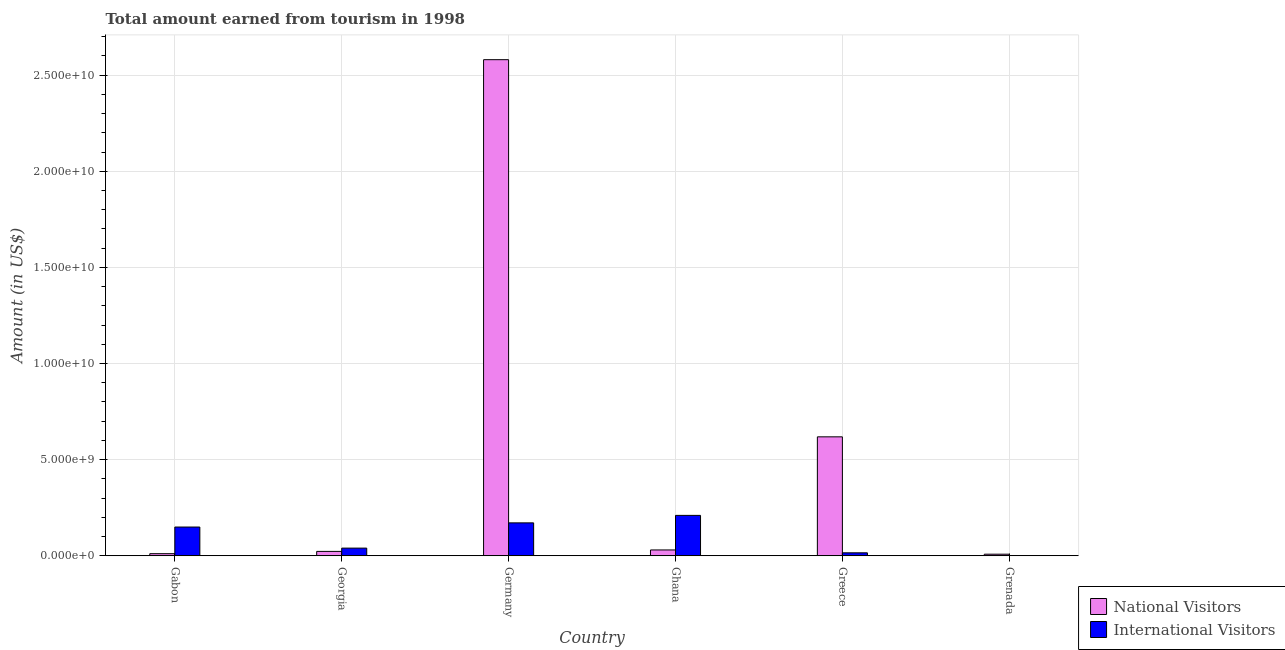Are the number of bars on each tick of the X-axis equal?
Your answer should be compact. Yes. How many bars are there on the 3rd tick from the left?
Ensure brevity in your answer.  2. What is the label of the 6th group of bars from the left?
Your response must be concise. Grenada. What is the amount earned from international visitors in Grenada?
Provide a succinct answer. 1.40e+07. Across all countries, what is the maximum amount earned from international visitors?
Offer a terse response. 2.10e+09. Across all countries, what is the minimum amount earned from international visitors?
Keep it short and to the point. 1.40e+07. In which country was the amount earned from international visitors maximum?
Your answer should be compact. Ghana. In which country was the amount earned from international visitors minimum?
Your answer should be compact. Grenada. What is the total amount earned from national visitors in the graph?
Your answer should be very brief. 3.27e+1. What is the difference between the amount earned from international visitors in Ghana and that in Grenada?
Provide a short and direct response. 2.09e+09. What is the difference between the amount earned from international visitors in Georgia and the amount earned from national visitors in Greece?
Keep it short and to the point. -5.79e+09. What is the average amount earned from international visitors per country?
Keep it short and to the point. 9.80e+08. What is the difference between the amount earned from international visitors and amount earned from national visitors in Grenada?
Your answer should be very brief. -6.90e+07. What is the ratio of the amount earned from international visitors in Germany to that in Grenada?
Your response must be concise. 122.36. Is the amount earned from international visitors in Gabon less than that in Grenada?
Give a very brief answer. No. What is the difference between the highest and the second highest amount earned from international visitors?
Give a very brief answer. 3.89e+08. What is the difference between the highest and the lowest amount earned from international visitors?
Give a very brief answer. 2.09e+09. In how many countries, is the amount earned from international visitors greater than the average amount earned from international visitors taken over all countries?
Keep it short and to the point. 3. Is the sum of the amount earned from national visitors in Germany and Grenada greater than the maximum amount earned from international visitors across all countries?
Offer a terse response. Yes. What does the 2nd bar from the left in Georgia represents?
Your response must be concise. International Visitors. What does the 1st bar from the right in Ghana represents?
Your answer should be very brief. International Visitors. How many bars are there?
Give a very brief answer. 12. Are all the bars in the graph horizontal?
Your response must be concise. No. How many countries are there in the graph?
Provide a short and direct response. 6. What is the difference between two consecutive major ticks on the Y-axis?
Ensure brevity in your answer.  5.00e+09. Are the values on the major ticks of Y-axis written in scientific E-notation?
Provide a short and direct response. Yes. Does the graph contain grids?
Make the answer very short. Yes. How many legend labels are there?
Provide a short and direct response. 2. How are the legend labels stacked?
Keep it short and to the point. Vertical. What is the title of the graph?
Make the answer very short. Total amount earned from tourism in 1998. What is the Amount (in US$) of National Visitors in Gabon?
Provide a short and direct response. 1.10e+08. What is the Amount (in US$) of International Visitors in Gabon?
Your response must be concise. 1.50e+09. What is the Amount (in US$) of National Visitors in Georgia?
Provide a short and direct response. 2.29e+08. What is the Amount (in US$) in International Visitors in Georgia?
Offer a terse response. 3.99e+08. What is the Amount (in US$) in National Visitors in Germany?
Your answer should be compact. 2.58e+1. What is the Amount (in US$) in International Visitors in Germany?
Your response must be concise. 1.71e+09. What is the Amount (in US$) of National Visitors in Ghana?
Give a very brief answer. 3.04e+08. What is the Amount (in US$) of International Visitors in Ghana?
Provide a short and direct response. 2.10e+09. What is the Amount (in US$) of National Visitors in Greece?
Offer a very short reply. 6.19e+09. What is the Amount (in US$) in International Visitors in Greece?
Your response must be concise. 1.55e+08. What is the Amount (in US$) in National Visitors in Grenada?
Ensure brevity in your answer.  8.30e+07. What is the Amount (in US$) of International Visitors in Grenada?
Provide a succinct answer. 1.40e+07. Across all countries, what is the maximum Amount (in US$) in National Visitors?
Your answer should be very brief. 2.58e+1. Across all countries, what is the maximum Amount (in US$) in International Visitors?
Your answer should be compact. 2.10e+09. Across all countries, what is the minimum Amount (in US$) of National Visitors?
Your answer should be very brief. 8.30e+07. Across all countries, what is the minimum Amount (in US$) of International Visitors?
Keep it short and to the point. 1.40e+07. What is the total Amount (in US$) in National Visitors in the graph?
Keep it short and to the point. 3.27e+1. What is the total Amount (in US$) in International Visitors in the graph?
Keep it short and to the point. 5.88e+09. What is the difference between the Amount (in US$) of National Visitors in Gabon and that in Georgia?
Keep it short and to the point. -1.19e+08. What is the difference between the Amount (in US$) of International Visitors in Gabon and that in Georgia?
Make the answer very short. 1.10e+09. What is the difference between the Amount (in US$) in National Visitors in Gabon and that in Germany?
Offer a very short reply. -2.57e+1. What is the difference between the Amount (in US$) of International Visitors in Gabon and that in Germany?
Keep it short and to the point. -2.17e+08. What is the difference between the Amount (in US$) in National Visitors in Gabon and that in Ghana?
Make the answer very short. -1.94e+08. What is the difference between the Amount (in US$) of International Visitors in Gabon and that in Ghana?
Ensure brevity in your answer.  -6.06e+08. What is the difference between the Amount (in US$) of National Visitors in Gabon and that in Greece?
Offer a very short reply. -6.08e+09. What is the difference between the Amount (in US$) of International Visitors in Gabon and that in Greece?
Give a very brief answer. 1.34e+09. What is the difference between the Amount (in US$) of National Visitors in Gabon and that in Grenada?
Your response must be concise. 2.70e+07. What is the difference between the Amount (in US$) of International Visitors in Gabon and that in Grenada?
Offer a very short reply. 1.48e+09. What is the difference between the Amount (in US$) in National Visitors in Georgia and that in Germany?
Your answer should be very brief. -2.56e+1. What is the difference between the Amount (in US$) in International Visitors in Georgia and that in Germany?
Provide a succinct answer. -1.31e+09. What is the difference between the Amount (in US$) in National Visitors in Georgia and that in Ghana?
Offer a terse response. -7.50e+07. What is the difference between the Amount (in US$) of International Visitors in Georgia and that in Ghana?
Ensure brevity in your answer.  -1.70e+09. What is the difference between the Amount (in US$) in National Visitors in Georgia and that in Greece?
Your response must be concise. -5.96e+09. What is the difference between the Amount (in US$) of International Visitors in Georgia and that in Greece?
Offer a very short reply. 2.44e+08. What is the difference between the Amount (in US$) of National Visitors in Georgia and that in Grenada?
Make the answer very short. 1.46e+08. What is the difference between the Amount (in US$) in International Visitors in Georgia and that in Grenada?
Your response must be concise. 3.85e+08. What is the difference between the Amount (in US$) of National Visitors in Germany and that in Ghana?
Provide a short and direct response. 2.55e+1. What is the difference between the Amount (in US$) of International Visitors in Germany and that in Ghana?
Make the answer very short. -3.89e+08. What is the difference between the Amount (in US$) of National Visitors in Germany and that in Greece?
Offer a terse response. 1.96e+1. What is the difference between the Amount (in US$) in International Visitors in Germany and that in Greece?
Your response must be concise. 1.56e+09. What is the difference between the Amount (in US$) of National Visitors in Germany and that in Grenada?
Make the answer very short. 2.57e+1. What is the difference between the Amount (in US$) of International Visitors in Germany and that in Grenada?
Offer a very short reply. 1.70e+09. What is the difference between the Amount (in US$) in National Visitors in Ghana and that in Greece?
Make the answer very short. -5.88e+09. What is the difference between the Amount (in US$) in International Visitors in Ghana and that in Greece?
Give a very brief answer. 1.95e+09. What is the difference between the Amount (in US$) in National Visitors in Ghana and that in Grenada?
Provide a succinct answer. 2.21e+08. What is the difference between the Amount (in US$) in International Visitors in Ghana and that in Grenada?
Provide a short and direct response. 2.09e+09. What is the difference between the Amount (in US$) in National Visitors in Greece and that in Grenada?
Offer a very short reply. 6.10e+09. What is the difference between the Amount (in US$) of International Visitors in Greece and that in Grenada?
Give a very brief answer. 1.41e+08. What is the difference between the Amount (in US$) in National Visitors in Gabon and the Amount (in US$) in International Visitors in Georgia?
Provide a short and direct response. -2.89e+08. What is the difference between the Amount (in US$) of National Visitors in Gabon and the Amount (in US$) of International Visitors in Germany?
Ensure brevity in your answer.  -1.60e+09. What is the difference between the Amount (in US$) of National Visitors in Gabon and the Amount (in US$) of International Visitors in Ghana?
Provide a succinct answer. -1.99e+09. What is the difference between the Amount (in US$) in National Visitors in Gabon and the Amount (in US$) in International Visitors in Greece?
Provide a short and direct response. -4.50e+07. What is the difference between the Amount (in US$) in National Visitors in Gabon and the Amount (in US$) in International Visitors in Grenada?
Your response must be concise. 9.60e+07. What is the difference between the Amount (in US$) in National Visitors in Georgia and the Amount (in US$) in International Visitors in Germany?
Offer a terse response. -1.48e+09. What is the difference between the Amount (in US$) of National Visitors in Georgia and the Amount (in US$) of International Visitors in Ghana?
Your answer should be compact. -1.87e+09. What is the difference between the Amount (in US$) of National Visitors in Georgia and the Amount (in US$) of International Visitors in Greece?
Offer a very short reply. 7.40e+07. What is the difference between the Amount (in US$) in National Visitors in Georgia and the Amount (in US$) in International Visitors in Grenada?
Provide a short and direct response. 2.15e+08. What is the difference between the Amount (in US$) of National Visitors in Germany and the Amount (in US$) of International Visitors in Ghana?
Your answer should be very brief. 2.37e+1. What is the difference between the Amount (in US$) in National Visitors in Germany and the Amount (in US$) in International Visitors in Greece?
Offer a very short reply. 2.57e+1. What is the difference between the Amount (in US$) of National Visitors in Germany and the Amount (in US$) of International Visitors in Grenada?
Ensure brevity in your answer.  2.58e+1. What is the difference between the Amount (in US$) of National Visitors in Ghana and the Amount (in US$) of International Visitors in Greece?
Provide a succinct answer. 1.49e+08. What is the difference between the Amount (in US$) in National Visitors in Ghana and the Amount (in US$) in International Visitors in Grenada?
Your response must be concise. 2.90e+08. What is the difference between the Amount (in US$) in National Visitors in Greece and the Amount (in US$) in International Visitors in Grenada?
Provide a succinct answer. 6.17e+09. What is the average Amount (in US$) in National Visitors per country?
Provide a succinct answer. 5.45e+09. What is the average Amount (in US$) of International Visitors per country?
Provide a succinct answer. 9.80e+08. What is the difference between the Amount (in US$) of National Visitors and Amount (in US$) of International Visitors in Gabon?
Your answer should be very brief. -1.39e+09. What is the difference between the Amount (in US$) in National Visitors and Amount (in US$) in International Visitors in Georgia?
Provide a succinct answer. -1.70e+08. What is the difference between the Amount (in US$) in National Visitors and Amount (in US$) in International Visitors in Germany?
Offer a very short reply. 2.41e+1. What is the difference between the Amount (in US$) in National Visitors and Amount (in US$) in International Visitors in Ghana?
Provide a short and direct response. -1.80e+09. What is the difference between the Amount (in US$) of National Visitors and Amount (in US$) of International Visitors in Greece?
Make the answer very short. 6.03e+09. What is the difference between the Amount (in US$) of National Visitors and Amount (in US$) of International Visitors in Grenada?
Your answer should be compact. 6.90e+07. What is the ratio of the Amount (in US$) in National Visitors in Gabon to that in Georgia?
Your answer should be compact. 0.48. What is the ratio of the Amount (in US$) of International Visitors in Gabon to that in Georgia?
Keep it short and to the point. 3.75. What is the ratio of the Amount (in US$) in National Visitors in Gabon to that in Germany?
Your response must be concise. 0. What is the ratio of the Amount (in US$) of International Visitors in Gabon to that in Germany?
Give a very brief answer. 0.87. What is the ratio of the Amount (in US$) of National Visitors in Gabon to that in Ghana?
Your response must be concise. 0.36. What is the ratio of the Amount (in US$) of International Visitors in Gabon to that in Ghana?
Make the answer very short. 0.71. What is the ratio of the Amount (in US$) of National Visitors in Gabon to that in Greece?
Keep it short and to the point. 0.02. What is the ratio of the Amount (in US$) in International Visitors in Gabon to that in Greece?
Provide a short and direct response. 9.65. What is the ratio of the Amount (in US$) in National Visitors in Gabon to that in Grenada?
Your response must be concise. 1.33. What is the ratio of the Amount (in US$) of International Visitors in Gabon to that in Grenada?
Offer a terse response. 106.86. What is the ratio of the Amount (in US$) in National Visitors in Georgia to that in Germany?
Your response must be concise. 0.01. What is the ratio of the Amount (in US$) in International Visitors in Georgia to that in Germany?
Give a very brief answer. 0.23. What is the ratio of the Amount (in US$) of National Visitors in Georgia to that in Ghana?
Offer a very short reply. 0.75. What is the ratio of the Amount (in US$) of International Visitors in Georgia to that in Ghana?
Make the answer very short. 0.19. What is the ratio of the Amount (in US$) of National Visitors in Georgia to that in Greece?
Provide a succinct answer. 0.04. What is the ratio of the Amount (in US$) in International Visitors in Georgia to that in Greece?
Ensure brevity in your answer.  2.57. What is the ratio of the Amount (in US$) of National Visitors in Georgia to that in Grenada?
Provide a short and direct response. 2.76. What is the ratio of the Amount (in US$) of National Visitors in Germany to that in Ghana?
Offer a very short reply. 84.89. What is the ratio of the Amount (in US$) in International Visitors in Germany to that in Ghana?
Keep it short and to the point. 0.81. What is the ratio of the Amount (in US$) in National Visitors in Germany to that in Greece?
Make the answer very short. 4.17. What is the ratio of the Amount (in US$) of International Visitors in Germany to that in Greece?
Provide a succinct answer. 11.05. What is the ratio of the Amount (in US$) in National Visitors in Germany to that in Grenada?
Ensure brevity in your answer.  310.92. What is the ratio of the Amount (in US$) of International Visitors in Germany to that in Grenada?
Provide a short and direct response. 122.36. What is the ratio of the Amount (in US$) in National Visitors in Ghana to that in Greece?
Your answer should be compact. 0.05. What is the ratio of the Amount (in US$) of International Visitors in Ghana to that in Greece?
Make the answer very short. 13.56. What is the ratio of the Amount (in US$) of National Visitors in Ghana to that in Grenada?
Your response must be concise. 3.66. What is the ratio of the Amount (in US$) of International Visitors in Ghana to that in Grenada?
Provide a succinct answer. 150.14. What is the ratio of the Amount (in US$) of National Visitors in Greece to that in Grenada?
Your response must be concise. 74.55. What is the ratio of the Amount (in US$) in International Visitors in Greece to that in Grenada?
Your answer should be compact. 11.07. What is the difference between the highest and the second highest Amount (in US$) in National Visitors?
Give a very brief answer. 1.96e+1. What is the difference between the highest and the second highest Amount (in US$) in International Visitors?
Offer a terse response. 3.89e+08. What is the difference between the highest and the lowest Amount (in US$) of National Visitors?
Offer a very short reply. 2.57e+1. What is the difference between the highest and the lowest Amount (in US$) of International Visitors?
Provide a succinct answer. 2.09e+09. 